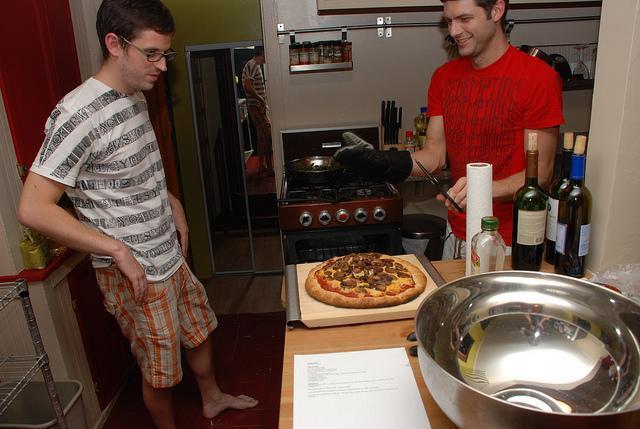How many ovens can you see?
Give a very brief answer. 1. How many bottles can you see?
Give a very brief answer. 2. How many people are visible?
Give a very brief answer. 2. 